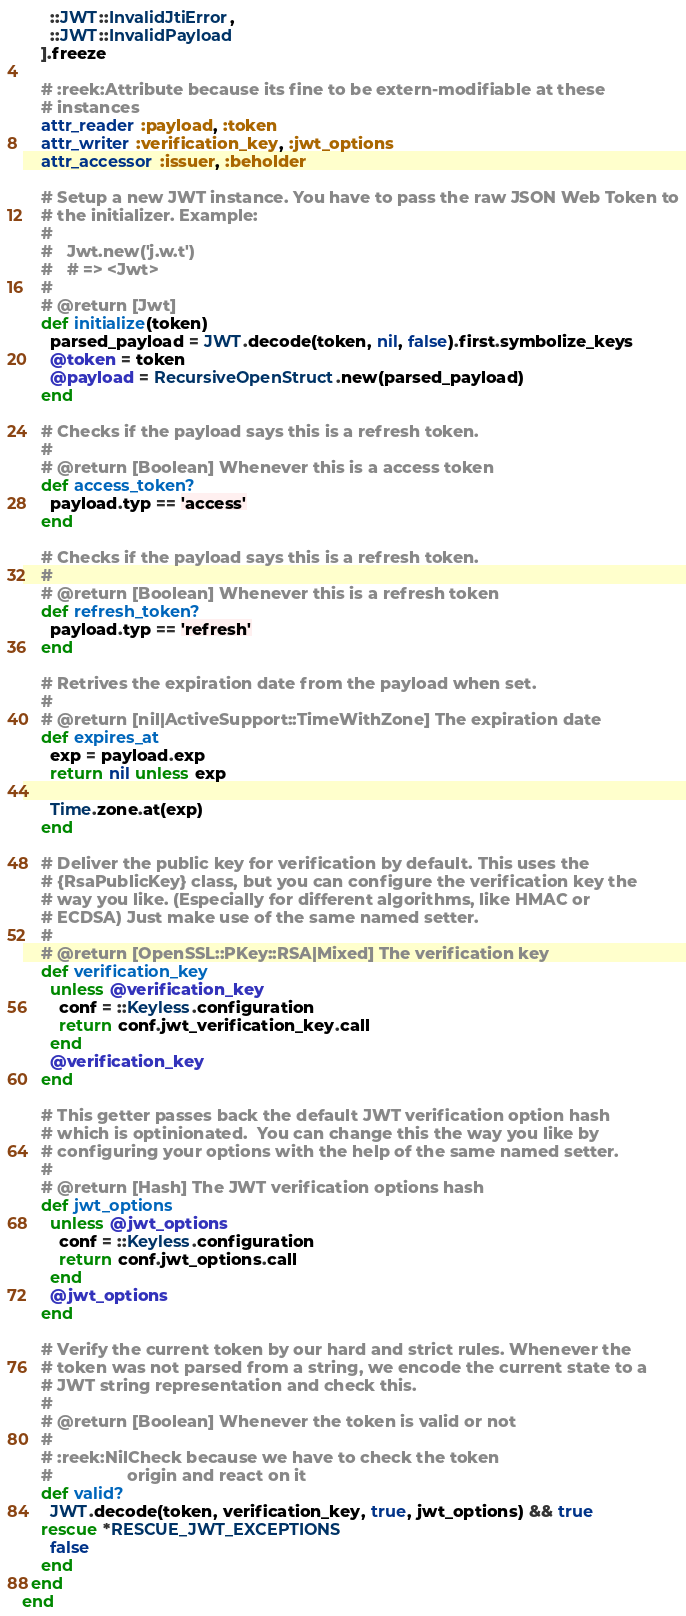Convert code to text. <code><loc_0><loc_0><loc_500><loc_500><_Ruby_>      ::JWT::InvalidJtiError,
      ::JWT::InvalidPayload
    ].freeze

    # :reek:Attribute because its fine to be extern-modifiable at these
    # instances
    attr_reader :payload, :token
    attr_writer :verification_key, :jwt_options
    attr_accessor :issuer, :beholder

    # Setup a new JWT instance. You have to pass the raw JSON Web Token to
    # the initializer. Example:
    #
    #   Jwt.new('j.w.t')
    #   # => <Jwt>
    #
    # @return [Jwt]
    def initialize(token)
      parsed_payload = JWT.decode(token, nil, false).first.symbolize_keys
      @token = token
      @payload = RecursiveOpenStruct.new(parsed_payload)
    end

    # Checks if the payload says this is a refresh token.
    #
    # @return [Boolean] Whenever this is a access token
    def access_token?
      payload.typ == 'access'
    end

    # Checks if the payload says this is a refresh token.
    #
    # @return [Boolean] Whenever this is a refresh token
    def refresh_token?
      payload.typ == 'refresh'
    end

    # Retrives the expiration date from the payload when set.
    #
    # @return [nil|ActiveSupport::TimeWithZone] The expiration date
    def expires_at
      exp = payload.exp
      return nil unless exp

      Time.zone.at(exp)
    end

    # Deliver the public key for verification by default. This uses the
    # {RsaPublicKey} class, but you can configure the verification key the
    # way you like. (Especially for different algorithms, like HMAC or
    # ECDSA) Just make use of the same named setter.
    #
    # @return [OpenSSL::PKey::RSA|Mixed] The verification key
    def verification_key
      unless @verification_key
        conf = ::Keyless.configuration
        return conf.jwt_verification_key.call
      end
      @verification_key
    end

    # This getter passes back the default JWT verification option hash
    # which is optinionated.  You can change this the way you like by
    # configuring your options with the help of the same named setter.
    #
    # @return [Hash] The JWT verification options hash
    def jwt_options
      unless @jwt_options
        conf = ::Keyless.configuration
        return conf.jwt_options.call
      end
      @jwt_options
    end

    # Verify the current token by our hard and strict rules. Whenever the
    # token was not parsed from a string, we encode the current state to a
    # JWT string representation and check this.
    #
    # @return [Boolean] Whenever the token is valid or not
    #
    # :reek:NilCheck because we have to check the token
    #                origin and react on it
    def valid?
      JWT.decode(token, verification_key, true, jwt_options) && true
    rescue *RESCUE_JWT_EXCEPTIONS
      false
    end
  end
end
</code> 